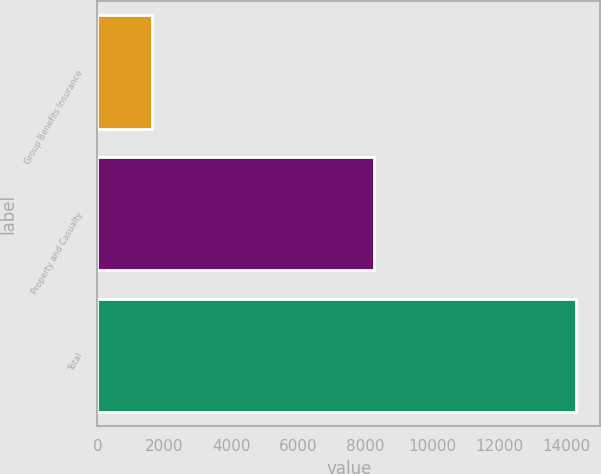Convert chart to OTSL. <chart><loc_0><loc_0><loc_500><loc_500><bar_chart><fcel>Group Benefits Insurance<fcel>Property and Casualty<fcel>Total<nl><fcel>1624<fcel>8261<fcel>14283<nl></chart> 